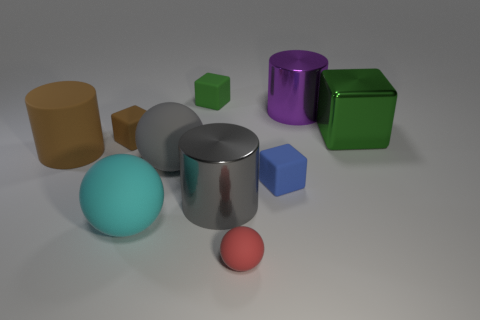How many green cubes must be subtracted to get 1 green cubes? 1 Subtract all cyan rubber spheres. How many spheres are left? 2 Subtract all blue cylinders. How many green blocks are left? 2 Subtract all gray cylinders. How many cylinders are left? 2 Subtract 3 cubes. How many cubes are left? 1 Subtract all cylinders. How many objects are left? 7 Subtract 0 brown balls. How many objects are left? 10 Subtract all purple cylinders. Subtract all brown blocks. How many cylinders are left? 2 Subtract all tiny brown matte cubes. Subtract all small matte cylinders. How many objects are left? 9 Add 4 gray objects. How many gray objects are left? 6 